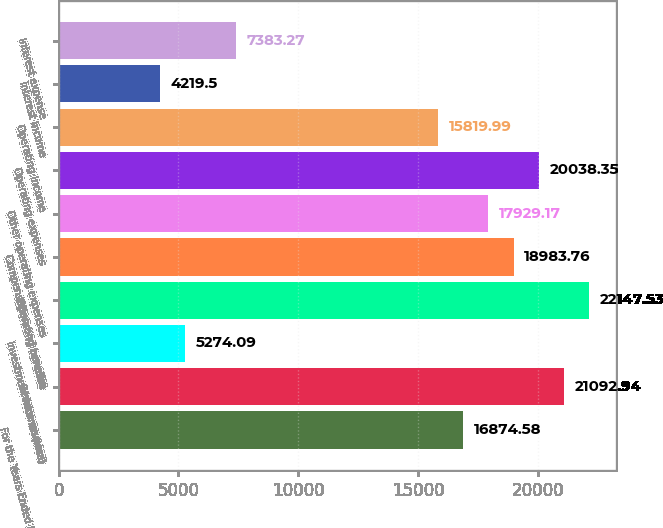Convert chart. <chart><loc_0><loc_0><loc_500><loc_500><bar_chart><fcel>For the Years Ended December<fcel>Service revenue<fcel>Investment income (loss)<fcel>Operating revenue<fcel>Compensation and benefits<fcel>Other operating expenses<fcel>Operating expenses<fcel>Operating income<fcel>Interest income<fcel>Interest expense<nl><fcel>16874.6<fcel>21092.9<fcel>5274.09<fcel>22147.5<fcel>18983.8<fcel>17929.2<fcel>20038.3<fcel>15820<fcel>4219.5<fcel>7383.27<nl></chart> 